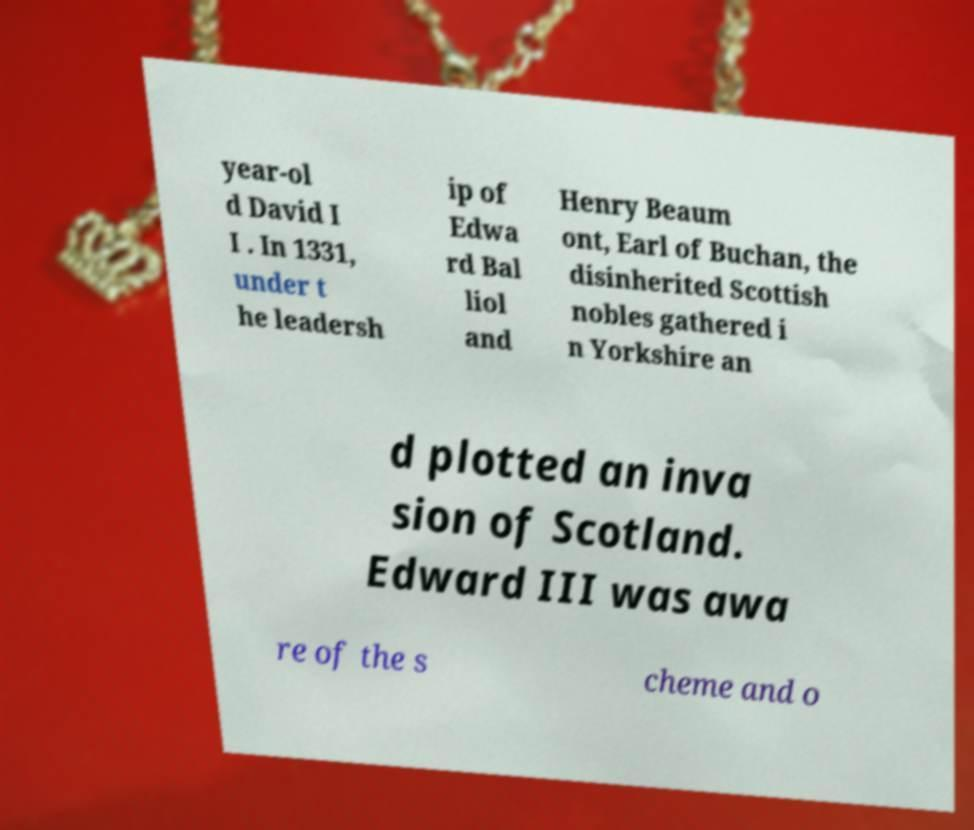Can you read and provide the text displayed in the image?This photo seems to have some interesting text. Can you extract and type it out for me? year-ol d David I I . In 1331, under t he leadersh ip of Edwa rd Bal liol and Henry Beaum ont, Earl of Buchan, the disinherited Scottish nobles gathered i n Yorkshire an d plotted an inva sion of Scotland. Edward III was awa re of the s cheme and o 